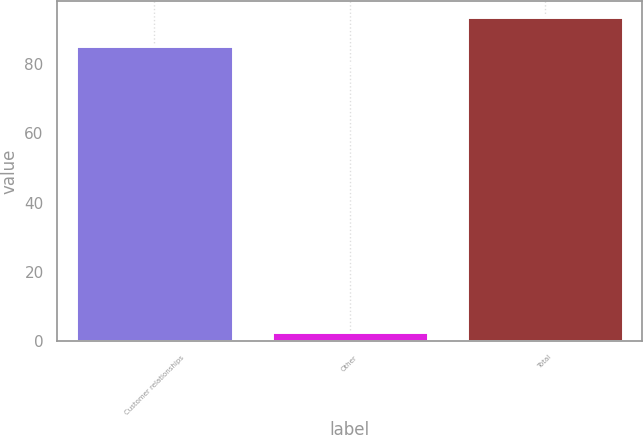<chart> <loc_0><loc_0><loc_500><loc_500><bar_chart><fcel>Customer relationships<fcel>Other<fcel>Total<nl><fcel>85<fcel>2.6<fcel>93.5<nl></chart> 